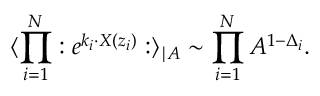Convert formula to latex. <formula><loc_0><loc_0><loc_500><loc_500>\langle \prod _ { i = 1 } ^ { N } \colon e ^ { k _ { i } \cdot X ( z _ { i } ) } \colon \rangle _ { | A } \sim \prod _ { i = 1 } ^ { N } A ^ { 1 - \Delta _ { i } } .</formula> 